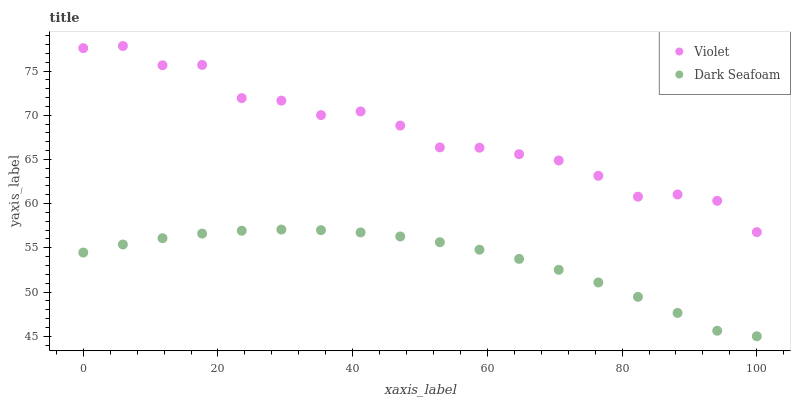Does Dark Seafoam have the minimum area under the curve?
Answer yes or no. Yes. Does Violet have the maximum area under the curve?
Answer yes or no. Yes. Does Violet have the minimum area under the curve?
Answer yes or no. No. Is Dark Seafoam the smoothest?
Answer yes or no. Yes. Is Violet the roughest?
Answer yes or no. Yes. Is Violet the smoothest?
Answer yes or no. No. Does Dark Seafoam have the lowest value?
Answer yes or no. Yes. Does Violet have the lowest value?
Answer yes or no. No. Does Violet have the highest value?
Answer yes or no. Yes. Is Dark Seafoam less than Violet?
Answer yes or no. Yes. Is Violet greater than Dark Seafoam?
Answer yes or no. Yes. Does Dark Seafoam intersect Violet?
Answer yes or no. No. 